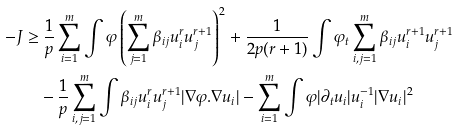<formula> <loc_0><loc_0><loc_500><loc_500>- J \geq & \ \frac { 1 } { p } \sum _ { i = 1 } ^ { m } \int \varphi \left ( \sum _ { j = 1 } ^ { m } \beta _ { i j } u _ { i } ^ { r } u _ { j } ^ { r + 1 } \right ) ^ { 2 } + \frac { 1 } { 2 p ( r + 1 ) } \int \varphi _ { t } \sum _ { i , j = 1 } ^ { m } \beta _ { i j } u _ { i } ^ { r + 1 } u _ { j } ^ { r + 1 } \\ & - \frac { 1 } { p } \sum _ { i , j = 1 } ^ { m } \int \beta _ { i j } u _ { i } ^ { r } u _ { j } ^ { r + 1 } | \nabla \varphi . \nabla u _ { i } | - \sum _ { i = 1 } ^ { m } \int \varphi | \partial _ { t } u _ { i } | u _ { i } ^ { - 1 } | \nabla u _ { i } | ^ { 2 }</formula> 